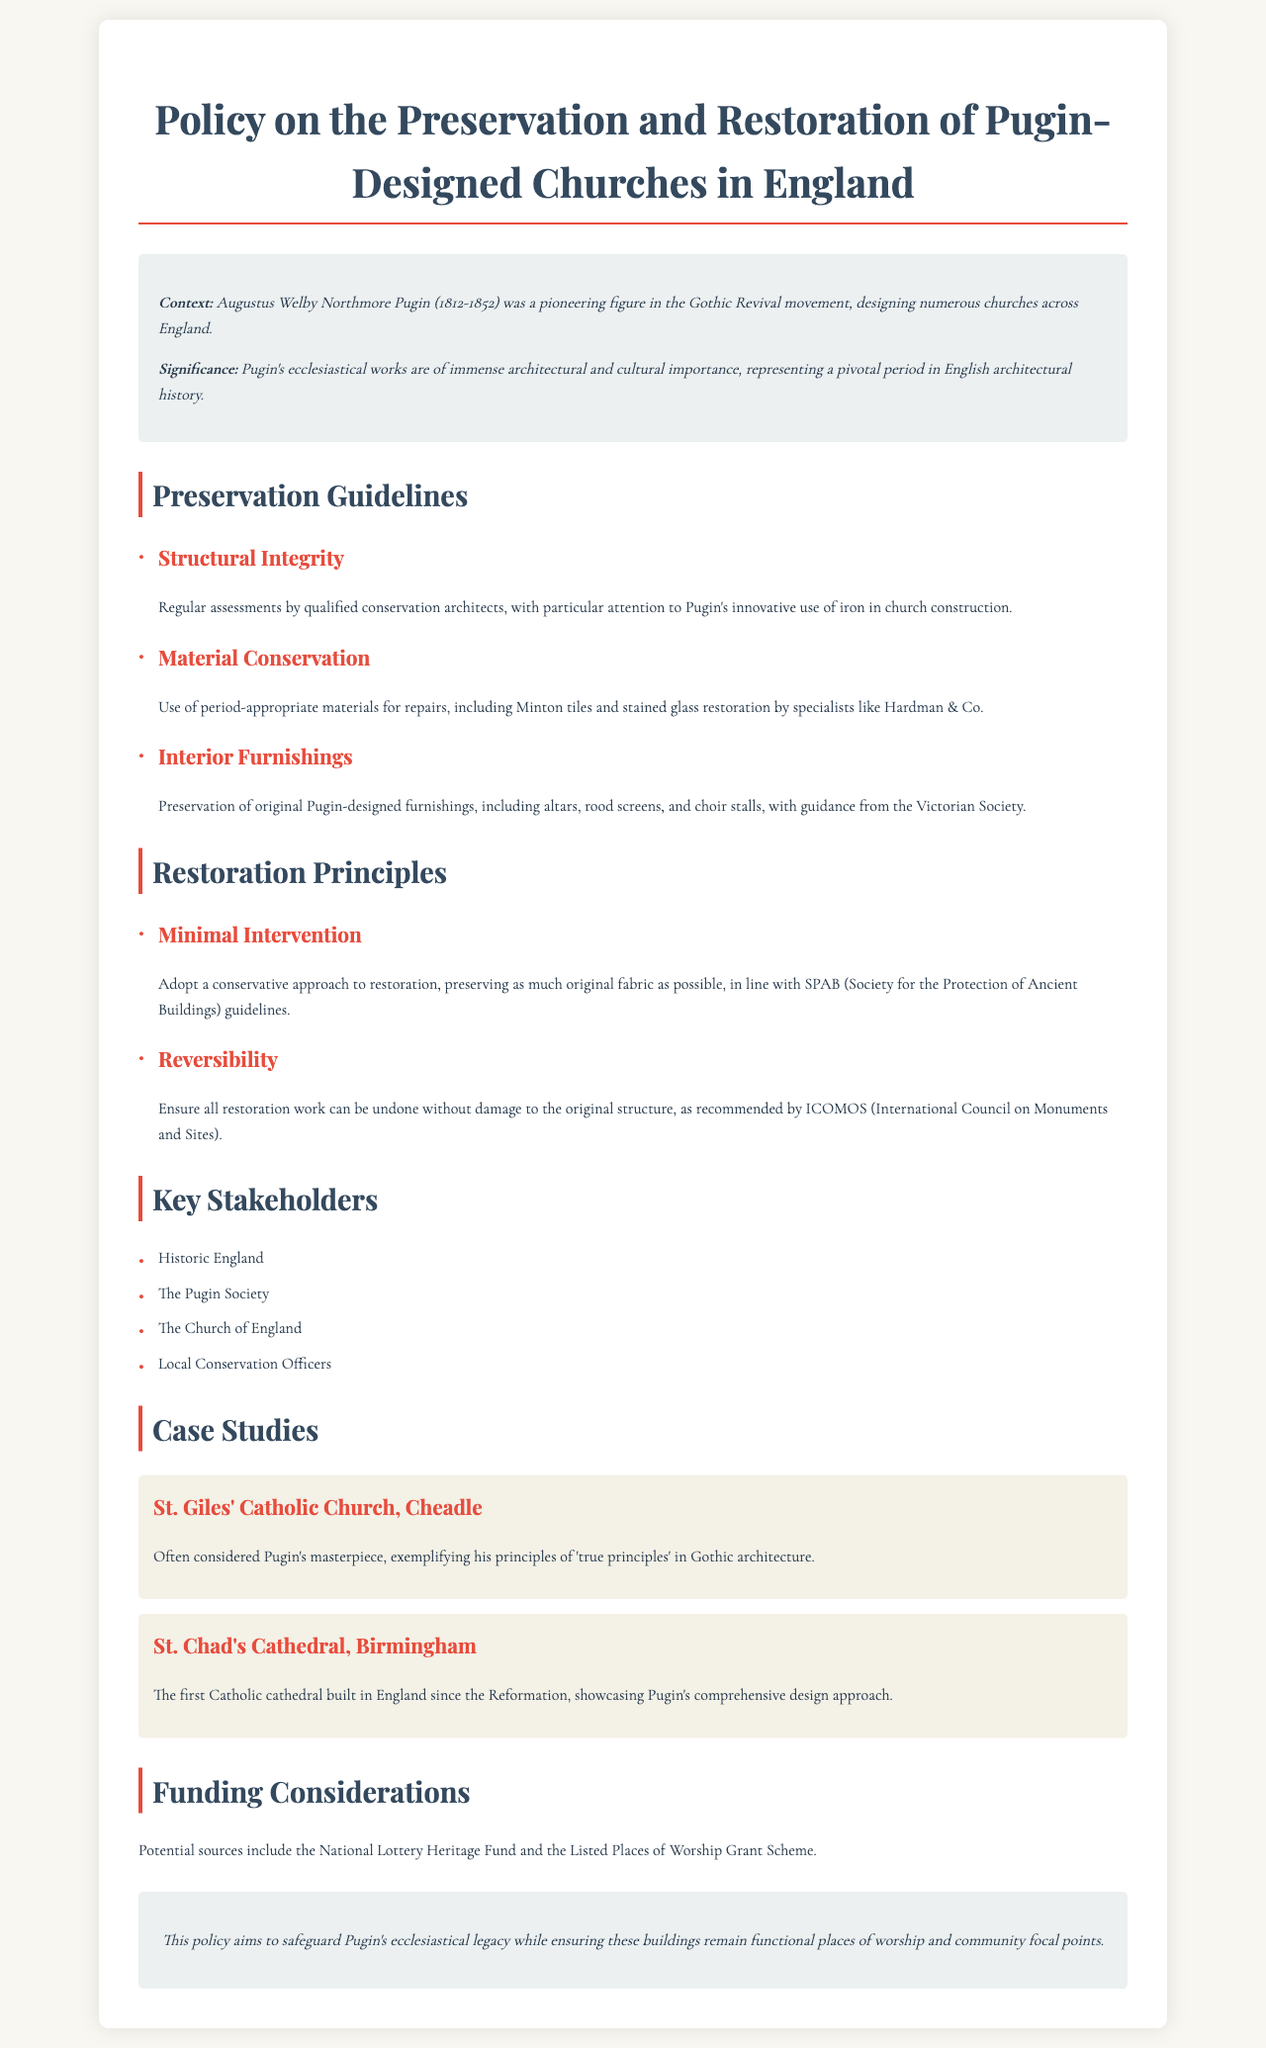what year was Augustus Pugin born? Augustus Pugin was born in 1812, which is stated in the introduction of the document.
Answer: 1812 what is the focus of Pugin's architectural significance? The document states that Pugin's ecclesiastical works represent a pivotal period in English architectural history, focusing on architecture.
Answer: ecclesiastical works which organization recommends a conservative approach to restoration? The document mentions SPAB (Society for the Protection of Ancient Buildings) as the organization that recommends a conservative approach.
Answer: SPAB how many case studies are provided in the document? The document lists two specific case studies in the section dedicated to case studies.
Answer: two who are the key stakeholders mentioned in the document? The document lists Historic England, The Pugin Society, The Church of England, and Local Conservation Officers as key stakeholders.
Answer: Historic England, The Pugin Society, The Church of England, Local Conservation Officers what is the first funding source listed in the funding considerations? The document indicates the National Lottery Heritage Fund as the first potential funding source.
Answer: National Lottery Heritage Fund what principle emphasizes that restoration work should be reversible? The document explicitly mentions the principle of reversibility in the section on restoration principles.
Answer: Reversibility which church is considered Pugin's masterpiece? The document identifies St. Giles' Catholic Church, Cheadle as Pugin's masterpiece.
Answer: St. Giles' Catholic Church, Cheadle 